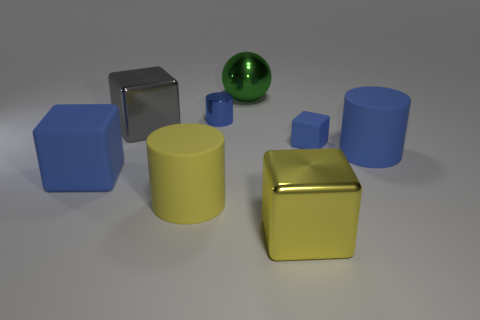Add 2 cyan shiny things. How many objects exist? 10 Subtract all cylinders. How many objects are left? 5 Add 3 big rubber objects. How many big rubber objects are left? 6 Add 3 big gray objects. How many big gray objects exist? 4 Subtract 0 brown cylinders. How many objects are left? 8 Subtract all tiny metallic balls. Subtract all blue shiny objects. How many objects are left? 7 